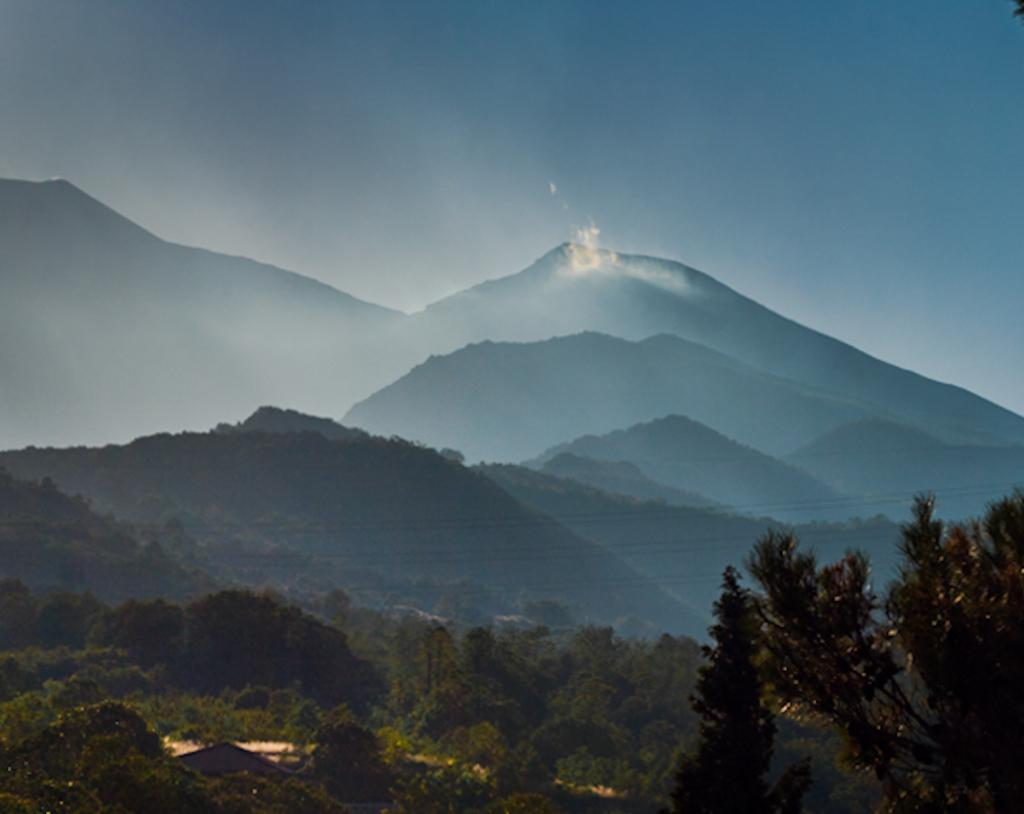What type of natural features can be seen in the image? There are trees and mountains in the image. What part of the natural environment is visible in the background of the image? The sky is visible in the background of the image. How does the image demonstrate the process of digestion? The image does not depict or demonstrate the process of digestion; it features trees, mountains, and the sky. 